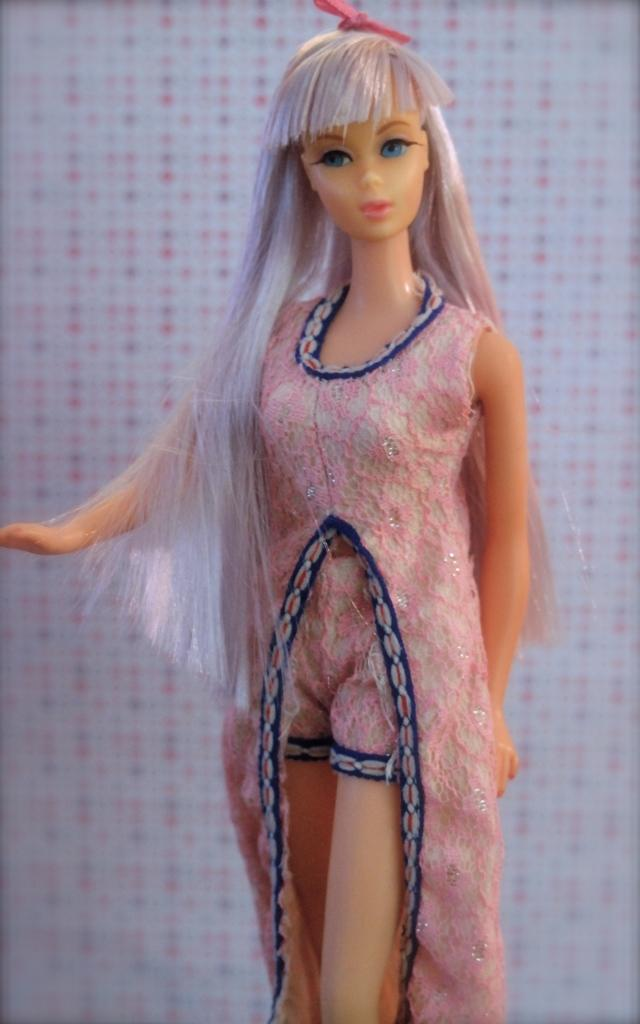What type of doll is present in the image? There is a Barbie doll in the image. What type of sponge is the Barbie doll using to clean the company's windows in the image? There is no sponge or company present in the image, and the Barbie doll is not cleaning any windows. 